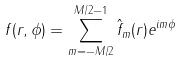<formula> <loc_0><loc_0><loc_500><loc_500>f ( r , \phi ) = \sum _ { m = - M / 2 } ^ { M / 2 - 1 } \hat { f } _ { m } ( r ) e ^ { i m \phi }</formula> 